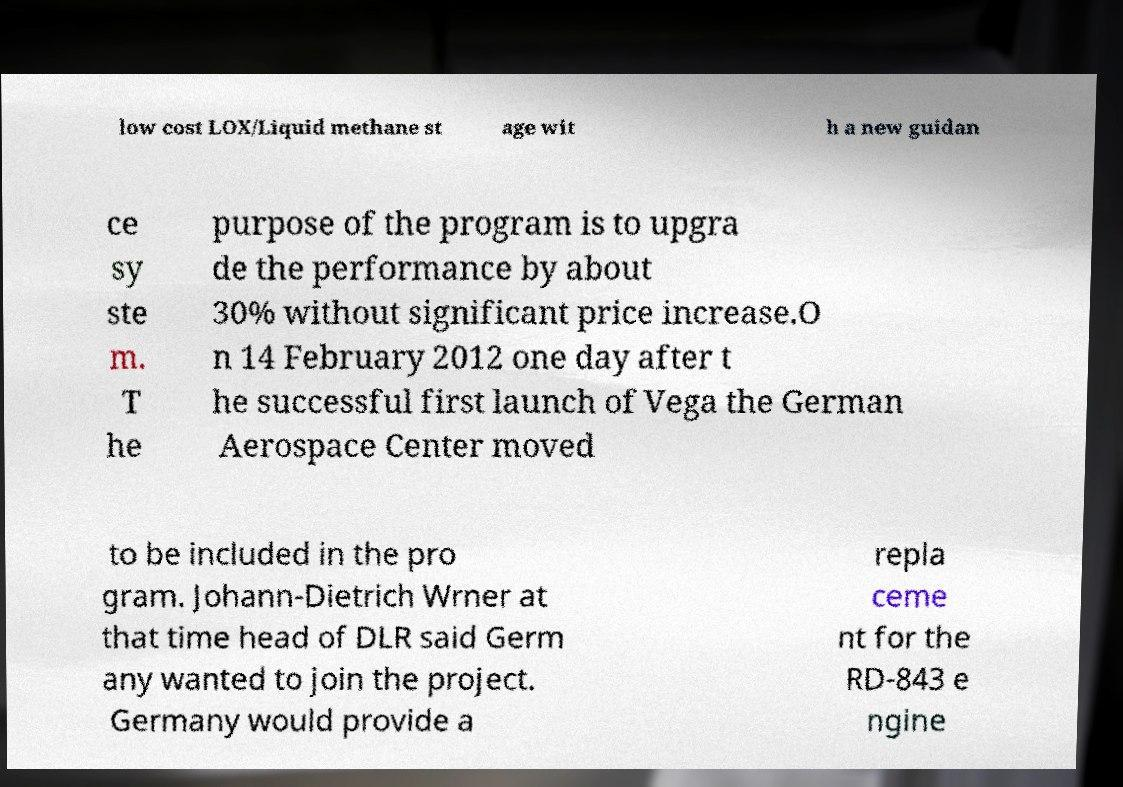Could you assist in decoding the text presented in this image and type it out clearly? low cost LOX/Liquid methane st age wit h a new guidan ce sy ste m. T he purpose of the program is to upgra de the performance by about 30% without significant price increase.O n 14 February 2012 one day after t he successful first launch of Vega the German Aerospace Center moved to be included in the pro gram. Johann-Dietrich Wrner at that time head of DLR said Germ any wanted to join the project. Germany would provide a repla ceme nt for the RD-843 e ngine 